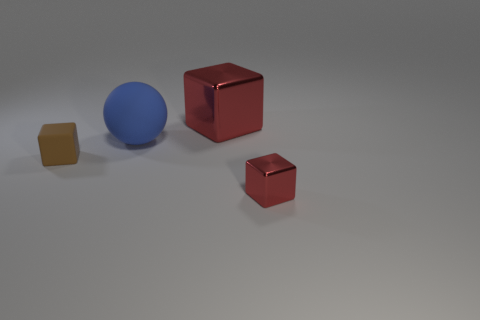What shape is the tiny metallic thing?
Provide a succinct answer. Cube. How many matte cubes have the same color as the tiny metallic thing?
Your answer should be very brief. 0. There is a red object that is the same size as the brown cube; what is its shape?
Your answer should be compact. Cube. Are there any purple matte cubes of the same size as the matte ball?
Keep it short and to the point. No. What is the material of the cube that is the same size as the blue matte sphere?
Your answer should be compact. Metal. There is a metallic object that is to the right of the red metal object that is left of the tiny red block; how big is it?
Provide a succinct answer. Small. There is a red cube in front of the brown matte object; is it the same size as the big red metal thing?
Ensure brevity in your answer.  No. Is the number of big red cubes behind the large red metallic thing greater than the number of blue rubber things left of the big sphere?
Your response must be concise. No. There is a object that is in front of the big rubber ball and on the left side of the small metallic block; what is its shape?
Offer a very short reply. Cube. There is a small thing that is to the left of the large shiny block; what is its shape?
Provide a succinct answer. Cube. 